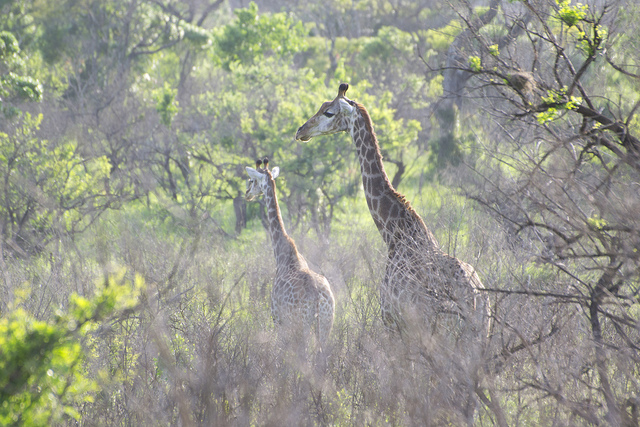<image>Where are the giraffe looking at? It is unclear where the giraffe is looking at. It might be looking at the woods or trees. Where are the giraffe looking at? I don't know where the giraffe is looking at. It can be looking at the woods, trees, or forest. 